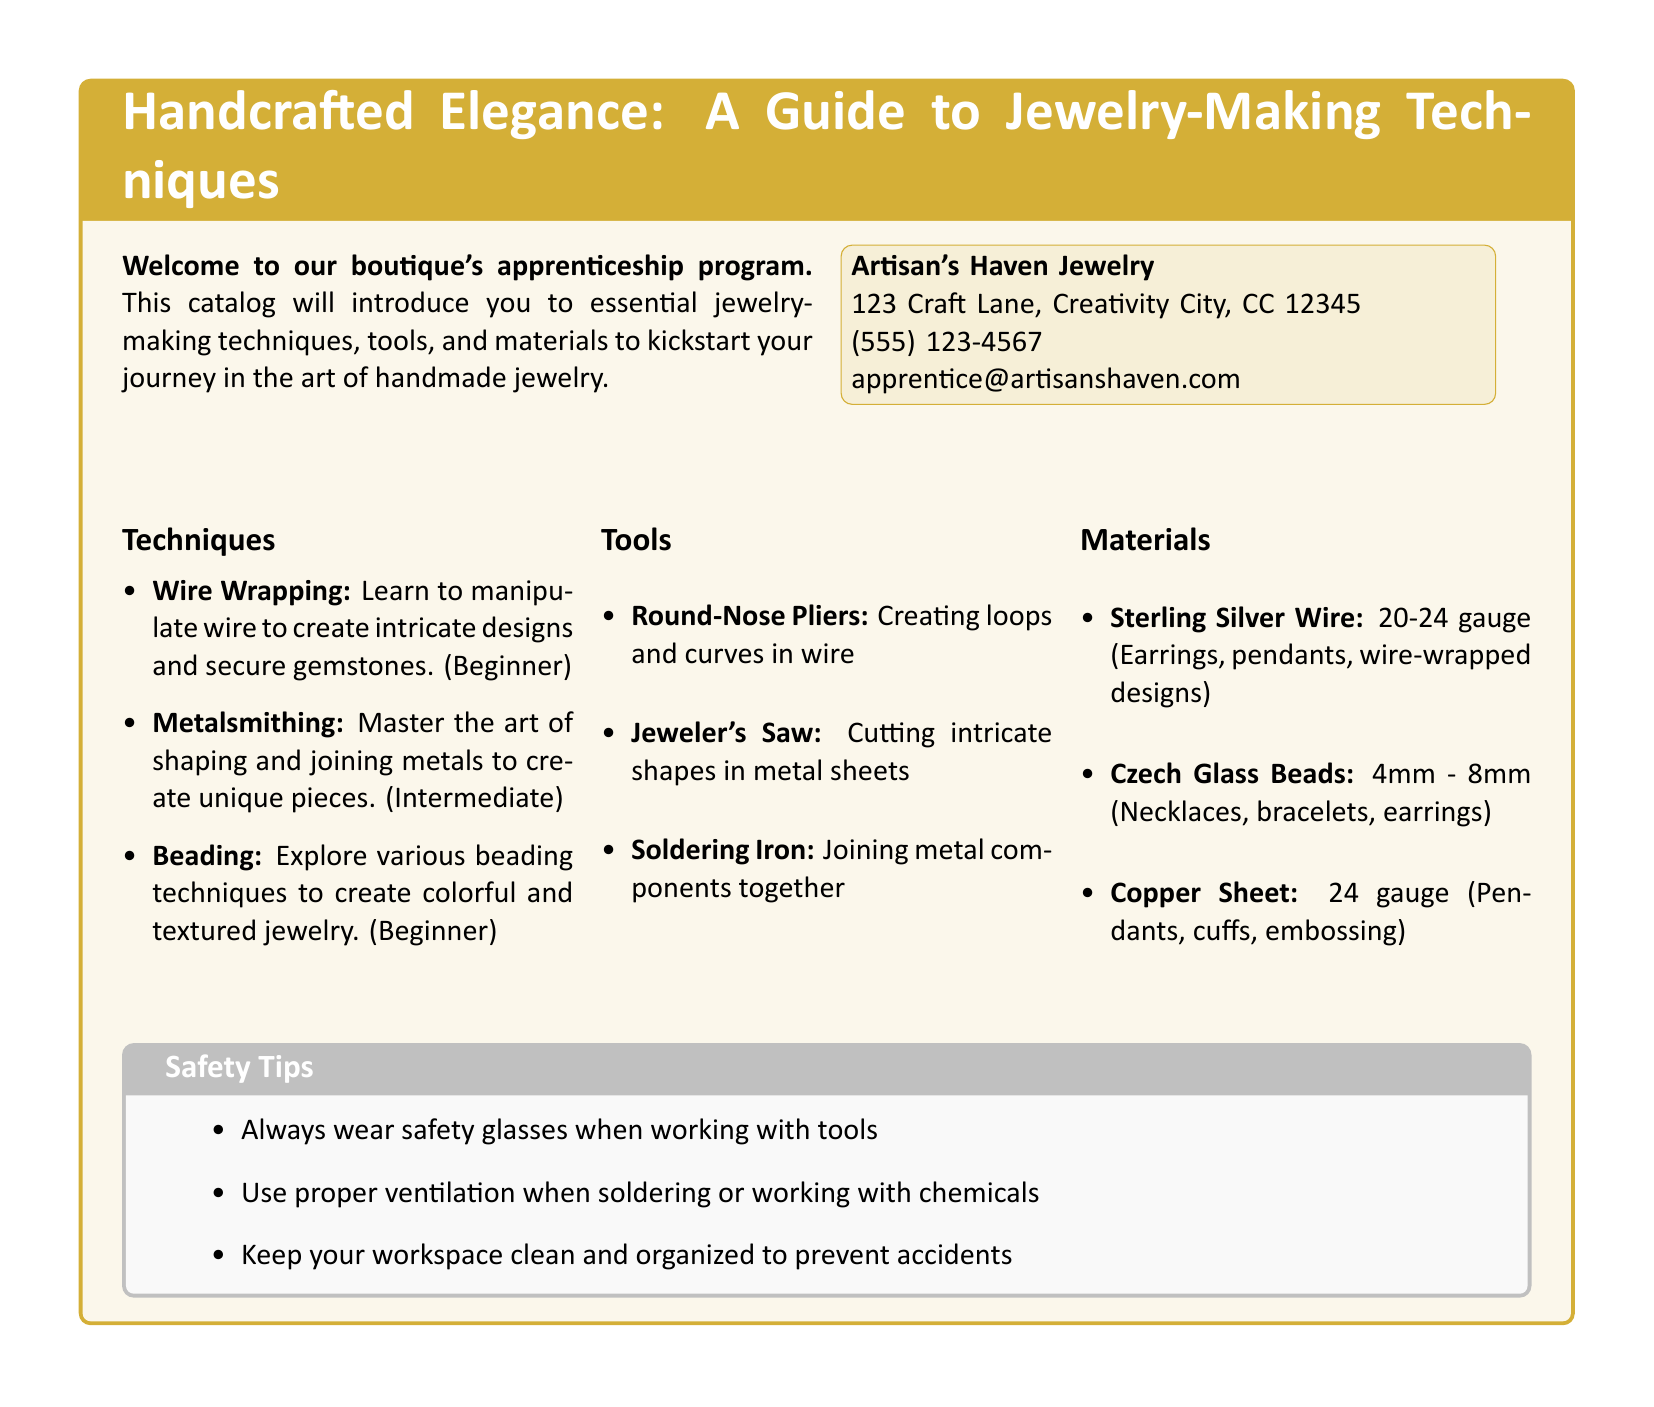What is the title of the catalog? The title is prominently displayed at the top of the document and reads "Handcrafted Elegance: A Guide to Jewelry-Making Techniques."
Answer: Handcrafted Elegance: A Guide to Jewelry-Making Techniques What is the address of Artisan's Haven Jewelry? The address is found in the contact information section of the document.
Answer: 123 Craft Lane, Creativity City, CC 12345 How many main techniques are listed in the document? The techniques section lists a total of three different techniques for jewelry-making.
Answer: 3 What tool is used for cutting intricate shapes in metal sheets? The document specifies a particular tool for this purpose clearly.
Answer: Jeweler's Saw What safety tip involves using safety glasses? The safety tips section includes a specific guideline related to eye protection while working.
Answer: Always wear safety glasses when working with tools Which technique is categorized as beginner level? The techniques section mentions multiple techniques and specifies their skill levels; one is marked as beginner.
Answer: Wire Wrapping What gauge of sterling silver wire is recommended for making earrings? The materials section specifies the gauge range suited for earrings and other items.
Answer: 20-24 gauge What type of beads are recommended for necklaces? The materials section includes a specific type of beads that are ideal for this jewelry piece.
Answer: Czech Glass Beads What is the purpose of using a soldering iron in jewelry-making? The tools section provides an explanation for the purpose of the soldering iron.
Answer: Joining metal components together 